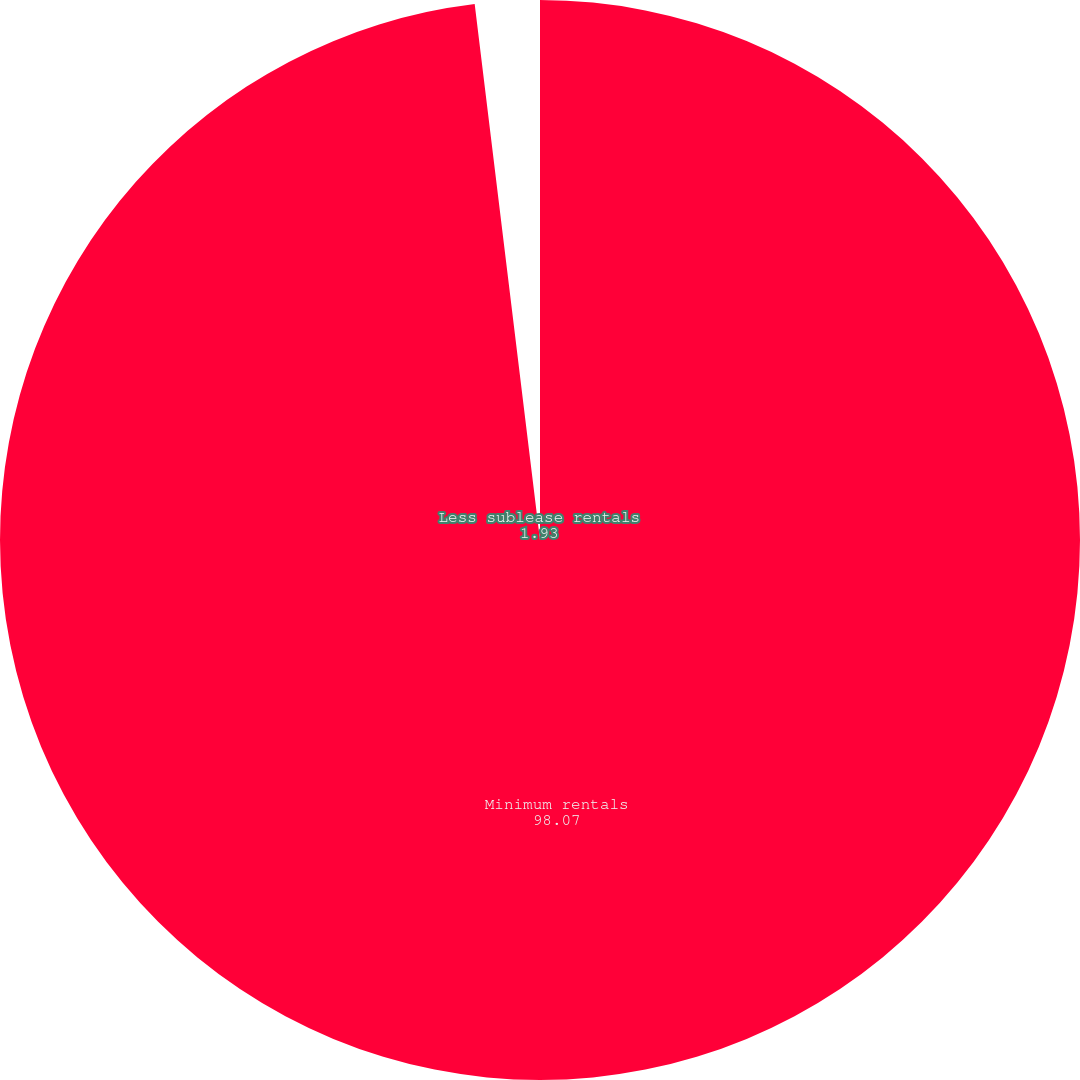Convert chart. <chart><loc_0><loc_0><loc_500><loc_500><pie_chart><fcel>Minimum rentals<fcel>Less sublease rentals<nl><fcel>98.07%<fcel>1.93%<nl></chart> 